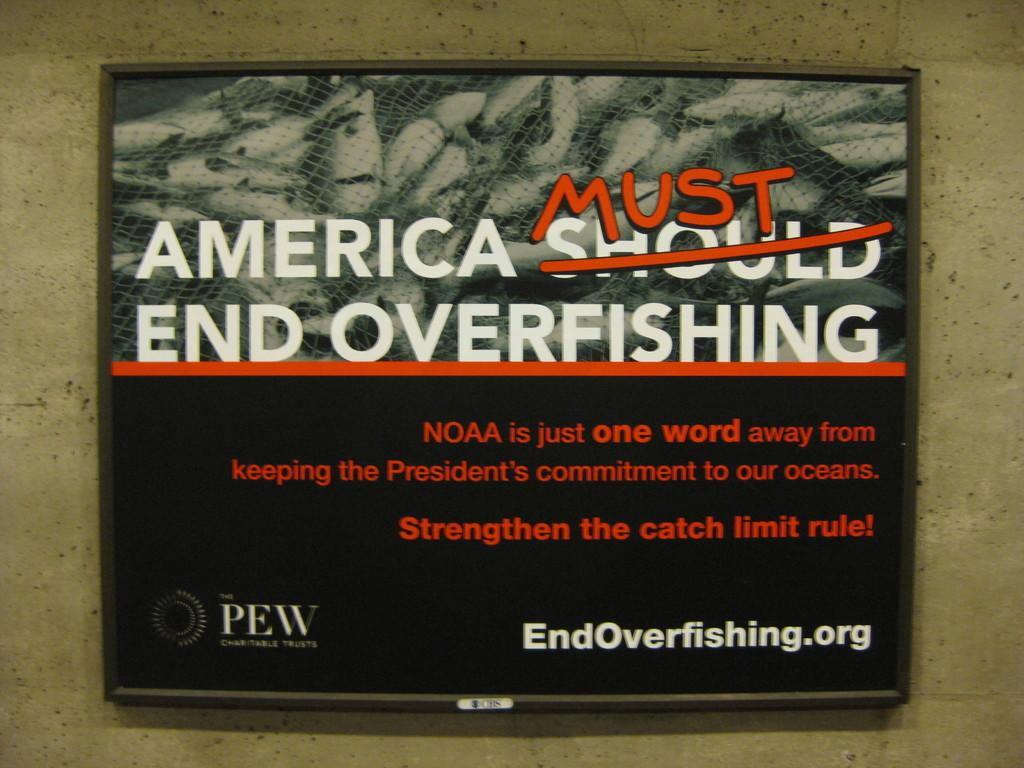What is the main object in the foreground of the image? There is a television or a frame displaying text in the image. What can be seen in the background of the image? There is a wall in the background of the image. How many knives are visible on the wall in the image? There are no knives visible on the wall in the image. Is there any smoke coming from the television or text frame in the image? There is no smoke present in the image. 